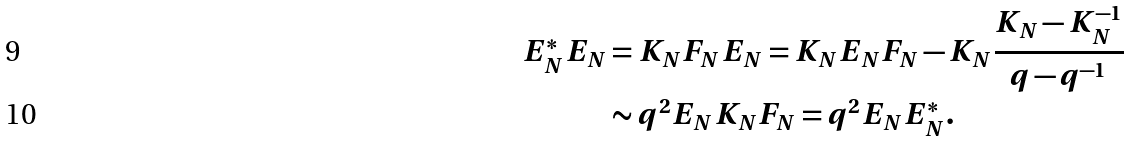<formula> <loc_0><loc_0><loc_500><loc_500>E _ { N } ^ { * } E _ { N } & = K _ { N } F _ { N } E _ { N } = K _ { N } E _ { N } F _ { N } - K _ { N } \frac { K _ { N } - K _ { N } ^ { - 1 } } { q - q ^ { - 1 } } \\ & \sim q ^ { 2 } E _ { N } K _ { N } F _ { N } = q ^ { 2 } E _ { N } E _ { N } ^ { * } .</formula> 